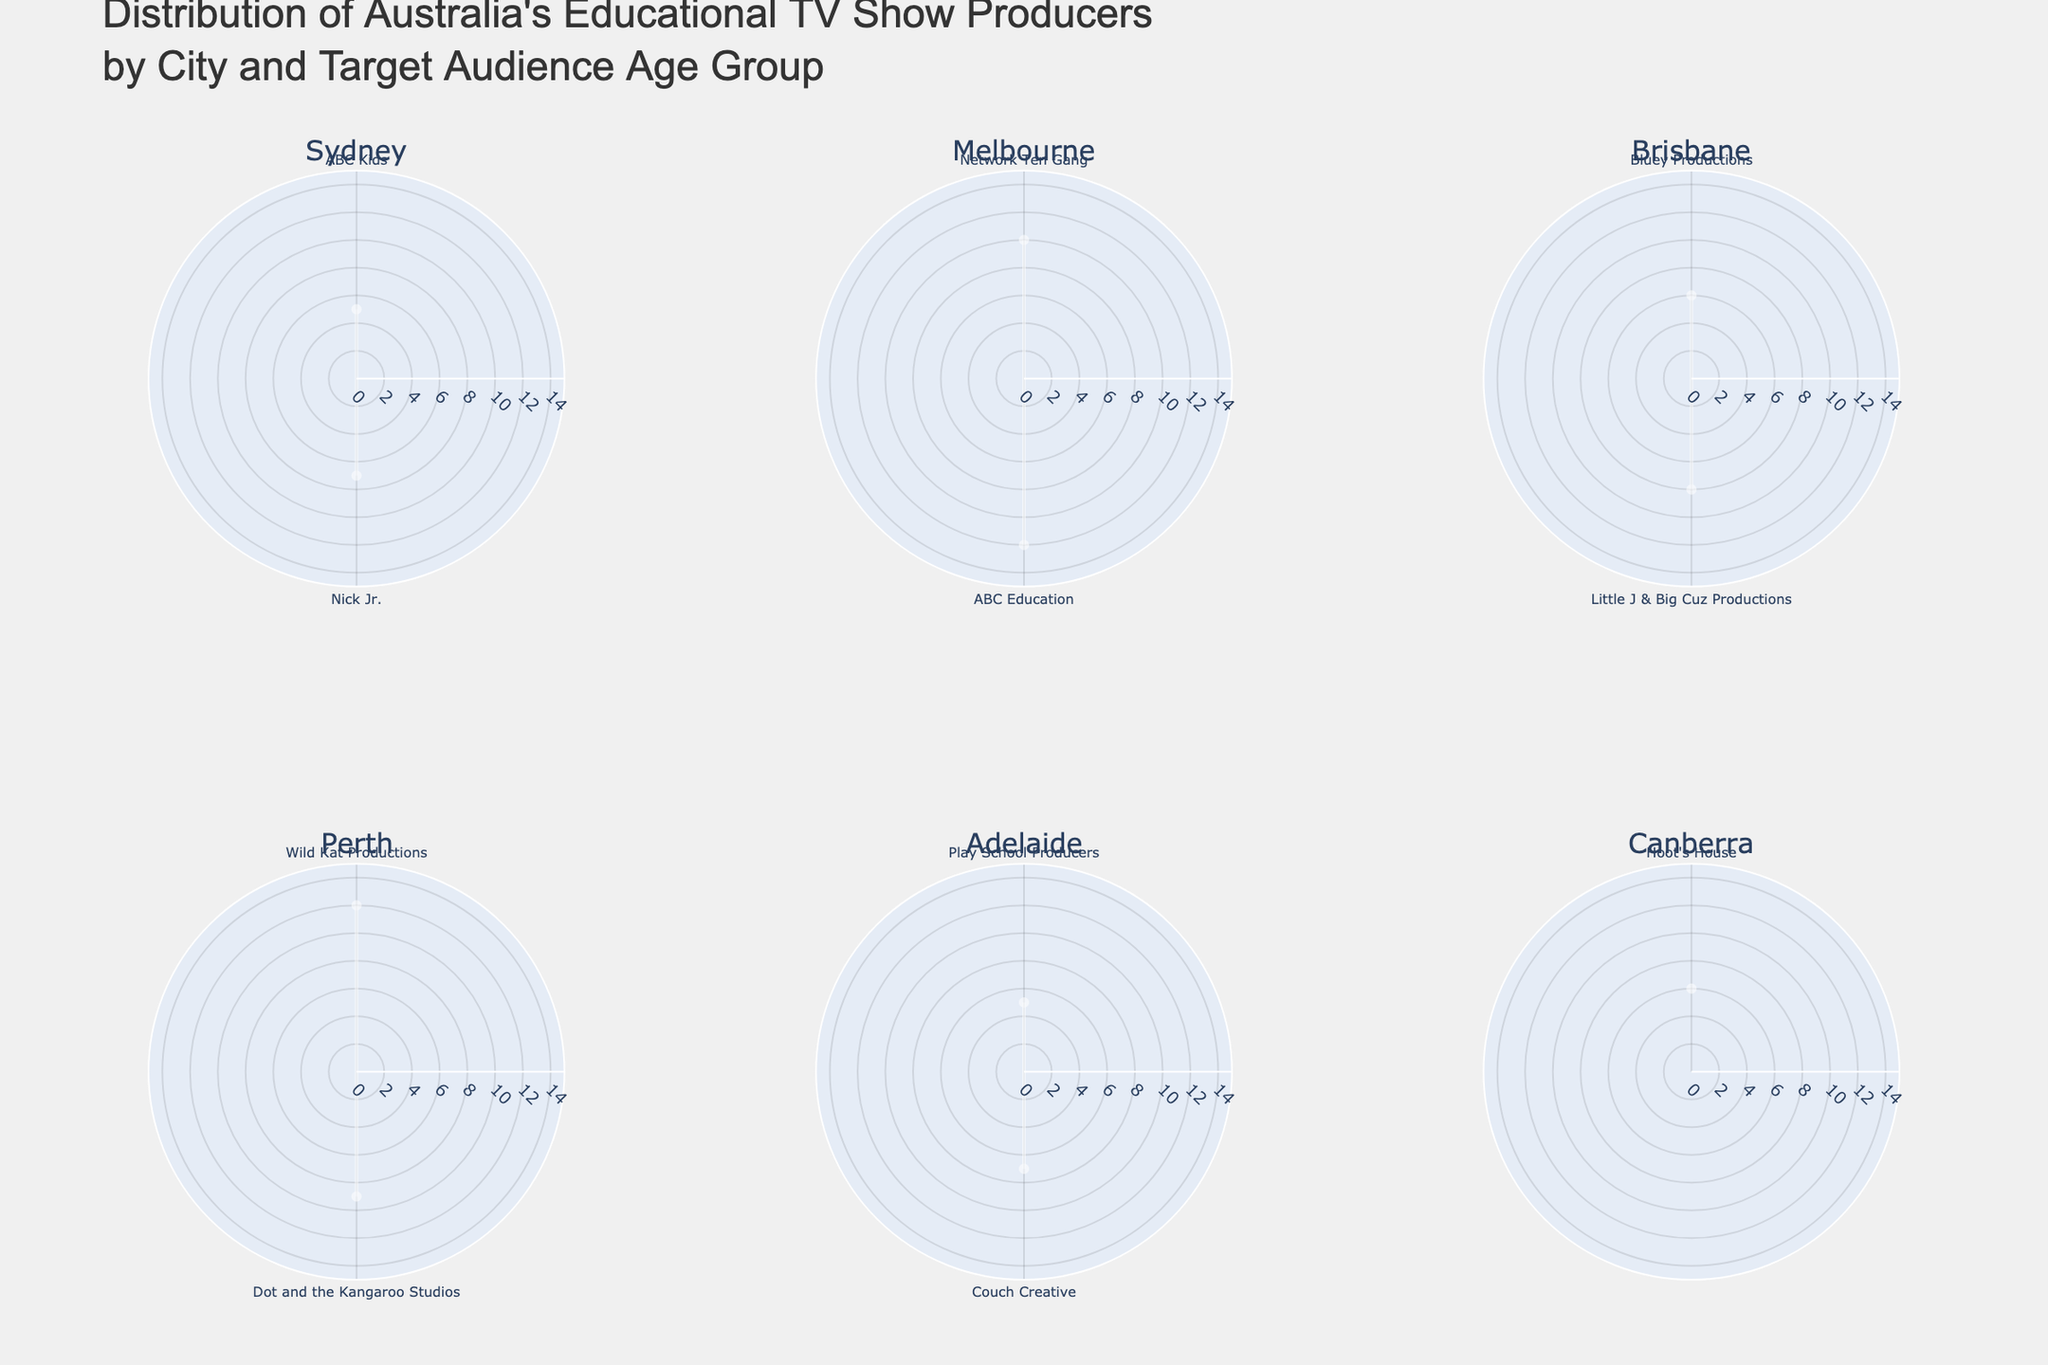What is the title of the figure? Look at the very top of the figure to find the title, which usually provides a summary of what the chart is displaying.
Answer: Distribution of Australia's Educational TV Show Producers by City and Target Audience Age Group Which city has the educational TV show producer 'Bluey Productions', and what is their target audience age group? Identify 'Bluey Productions' within one of the polar charts and observe the associated city and target audience age group.
Answer: Brisbane, 3-6 In the Melbourne subplot, what is the highest target audience age group? Look at the radial distances labeled for Melbourne's subplot and find the highest value.
Answer: 8-12 How many cities have educational TV show producers with a target audience age group smaller than 5 years old? Count the number of cities which have entries with age groups like 2-5 or 3-5.
Answer: 3 Compare Sydney and Melbourne based on the highest target audience age group. Which city has a broader target age range? Identify the highest target age groups for both Sydney and Melbourne subplots. Compare the values.
Answer: Melbourne How does Canberra's target audience age group for its educational TV show producer compare to Perth's youngest target age group? Find the target audience age groups for Canberra and compare it to the youngest target group in the Perth subplot.
Answer: Canberra: 3-6, Perth: 6-9 Which city has the educational TV show producer with the smallest target audience age group? Find the subplot with the radial distance corresponding to the smallest target age group (2-5).
Answer: Adelaide 